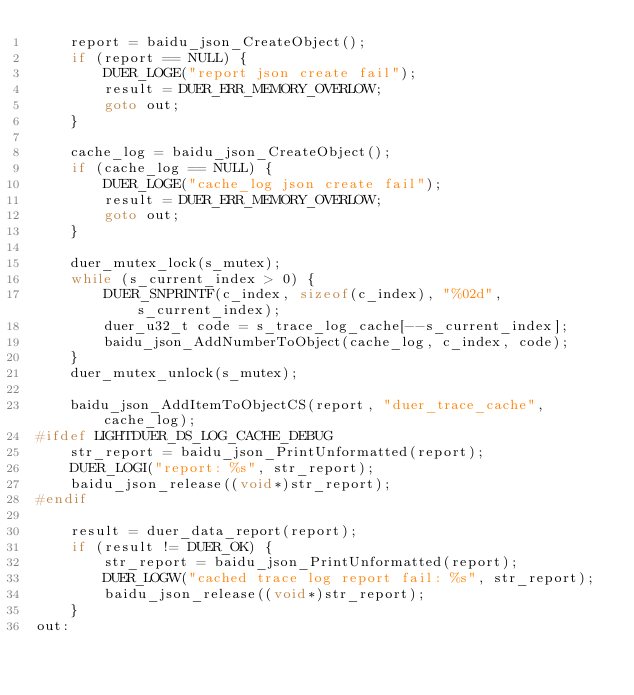Convert code to text. <code><loc_0><loc_0><loc_500><loc_500><_C_>    report = baidu_json_CreateObject();
    if (report == NULL) {
        DUER_LOGE("report json create fail");
        result = DUER_ERR_MEMORY_OVERLOW;
        goto out;
    }

    cache_log = baidu_json_CreateObject();
    if (cache_log == NULL) {
        DUER_LOGE("cache_log json create fail");
        result = DUER_ERR_MEMORY_OVERLOW;
        goto out;
    }

    duer_mutex_lock(s_mutex);
    while (s_current_index > 0) {
        DUER_SNPRINTF(c_index, sizeof(c_index), "%02d", s_current_index);
        duer_u32_t code = s_trace_log_cache[--s_current_index];
        baidu_json_AddNumberToObject(cache_log, c_index, code);
    }
    duer_mutex_unlock(s_mutex);

    baidu_json_AddItemToObjectCS(report, "duer_trace_cache", cache_log);
#ifdef LIGHTDUER_DS_LOG_CACHE_DEBUG
    str_report = baidu_json_PrintUnformatted(report);
    DUER_LOGI("report: %s", str_report);
    baidu_json_release((void*)str_report);
#endif

    result = duer_data_report(report);
    if (result != DUER_OK) {
        str_report = baidu_json_PrintUnformatted(report);
        DUER_LOGW("cached trace log report fail: %s", str_report);
        baidu_json_release((void*)str_report);
    }
out:</code> 